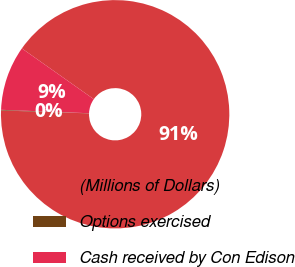Convert chart. <chart><loc_0><loc_0><loc_500><loc_500><pie_chart><fcel>(Millions of Dollars)<fcel>Options exercised<fcel>Cash received by Con Edison<nl><fcel>90.75%<fcel>0.09%<fcel>9.16%<nl></chart> 